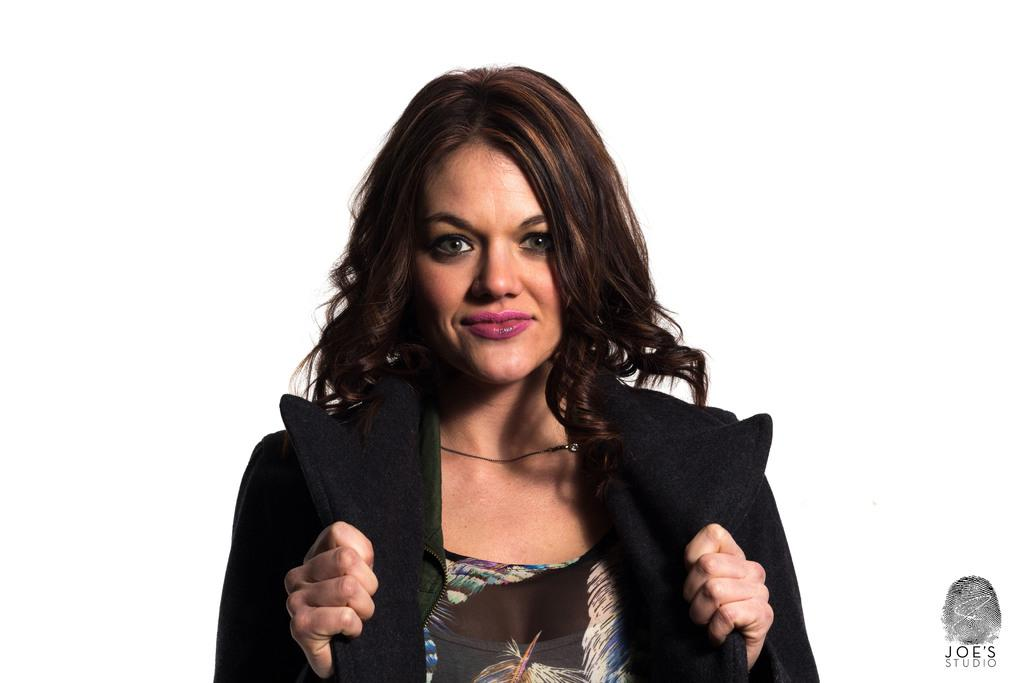Who is present in the image? There is a woman in the image. What is the woman wearing? The woman is wearing a jacket. What is the woman's facial expression in the image? The woman is smiling. What color is the background of the image? The background of the image is white. Can you describe any additional features of the image? There is a watermark in the bottom right corner of the image. What type of sense is the woman using to play chess in the image? There is no chess game or sense being used in the image; it only features a woman smiling in front of a white background. 